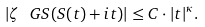<formula> <loc_0><loc_0><loc_500><loc_500>| \zeta _ { \ } G S ( S ( t ) + i t ) | \leq C \cdot | t | ^ { \kappa } .</formula> 